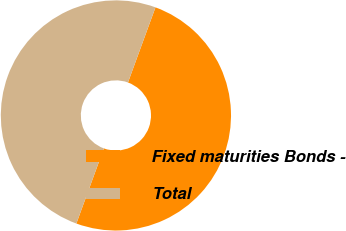Convert chart to OTSL. <chart><loc_0><loc_0><loc_500><loc_500><pie_chart><fcel>Fixed maturities Bonds -<fcel>Total<nl><fcel>50.0%<fcel>50.0%<nl></chart> 